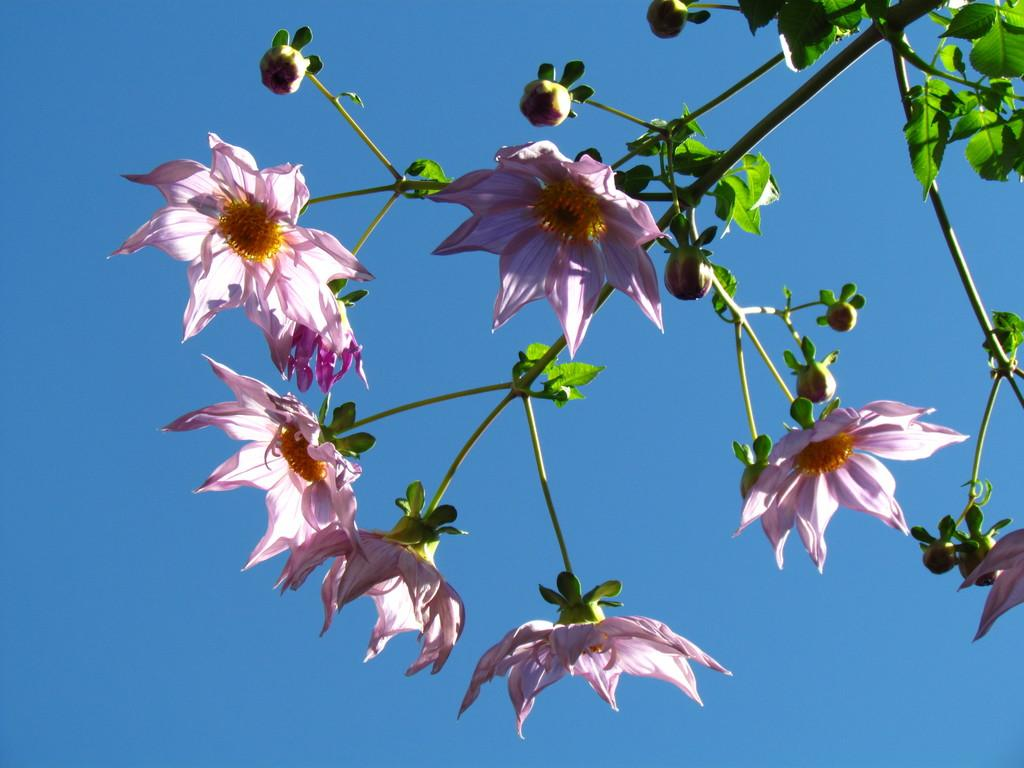What type of plant can be seen in the image? There is a tree in the image. What colors are present on the tree? The tree has pink color flowers and green color leaves. What can be seen in the background of the image? The background of the image includes a blue sky. What type of furniture is visible in the image? There is no furniture present in the image; it features a tree with pink flowers and green leaves against a blue sky. 